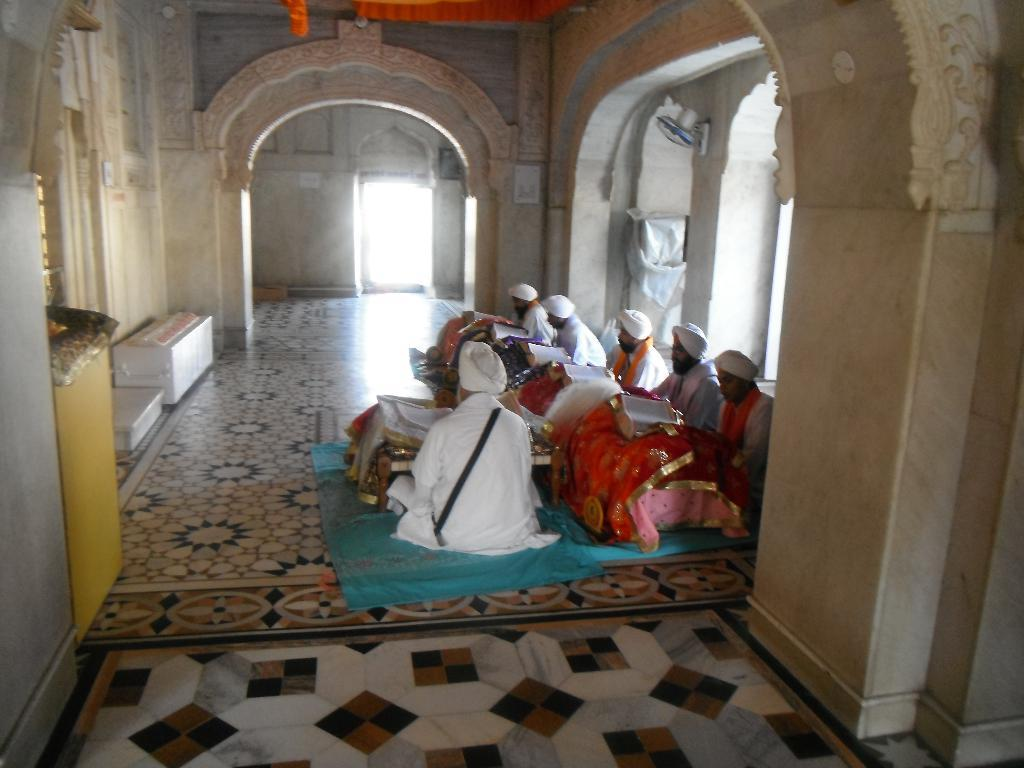What are the people in the image doing? The people in the image are sitting on the floor. What can be seen in the background of the image? There are walls visible in the image. What type of lace is being used to help with the business in the image? There is no lace, help, or business present in the image. 